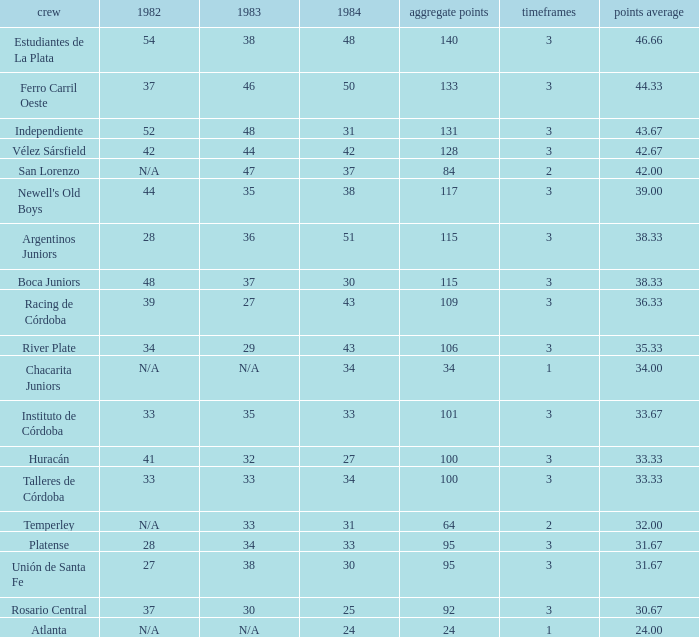What team had 3 seasons and fewer than 27 in 1984? Rosario Central. 